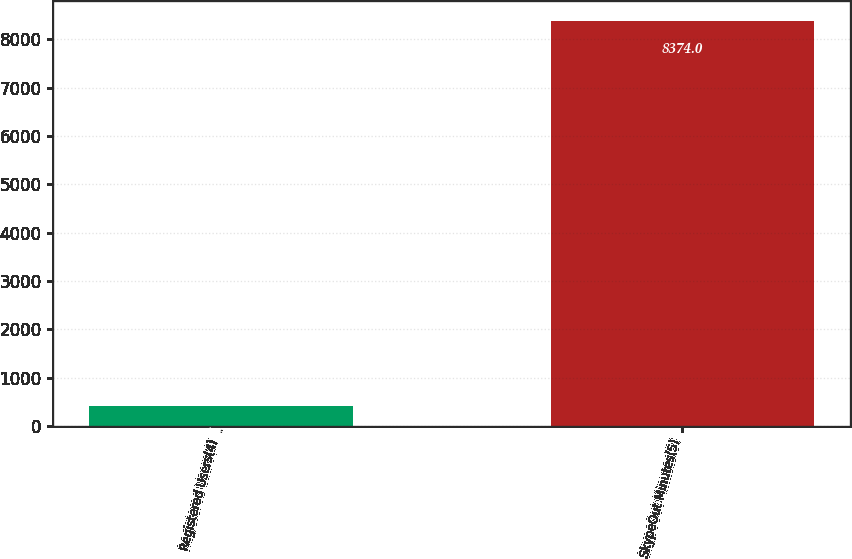<chart> <loc_0><loc_0><loc_500><loc_500><bar_chart><fcel>Registered Users(4)<fcel>SkypeOut Minutes(5)<nl><fcel>405.3<fcel>8374<nl></chart> 